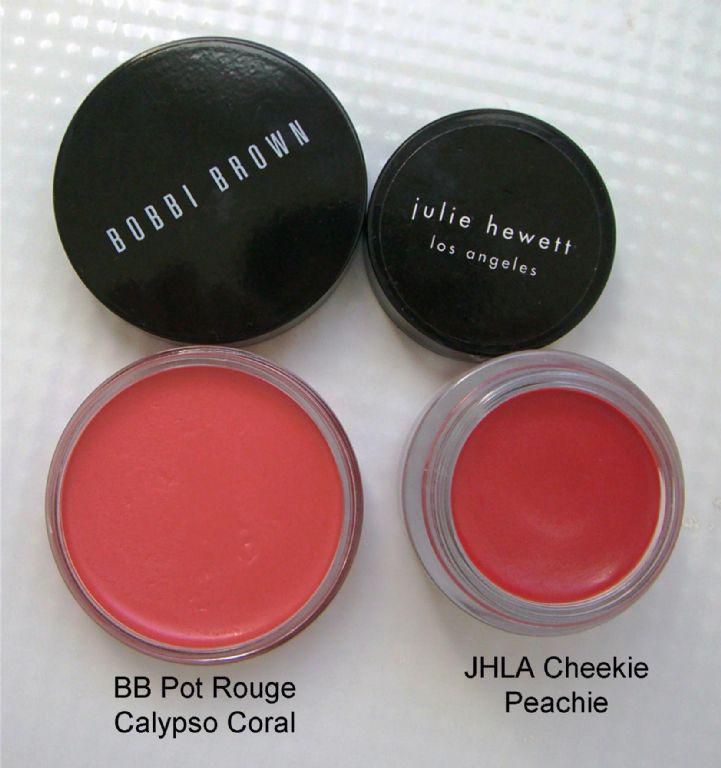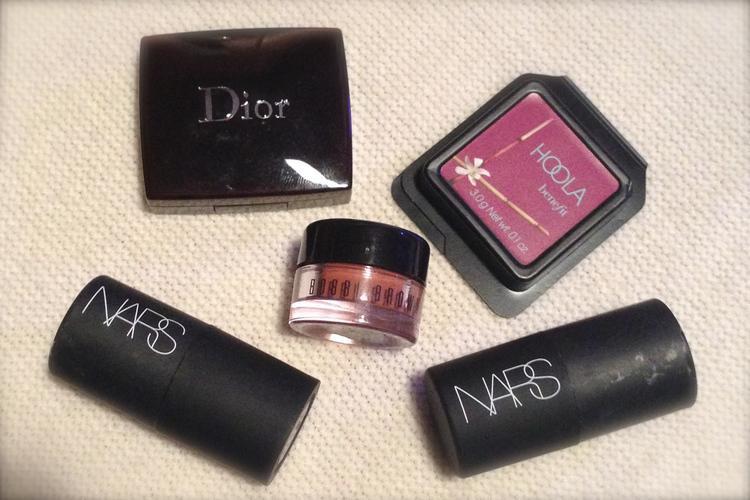The first image is the image on the left, the second image is the image on the right. Given the left and right images, does the statement "In one of the images the makeup is sitting upon a wooden surface." hold true? Answer yes or no. No. 